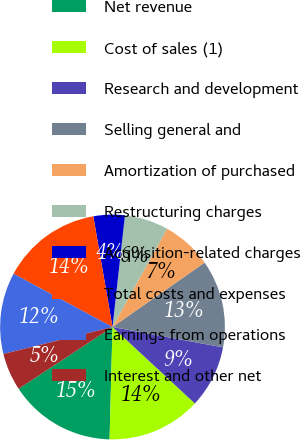<chart> <loc_0><loc_0><loc_500><loc_500><pie_chart><fcel>Net revenue<fcel>Cost of sales (1)<fcel>Research and development<fcel>Selling general and<fcel>Amortization of purchased<fcel>Restructuring charges<fcel>Acquisition-related charges<fcel>Total costs and expenses<fcel>Earnings from operations<fcel>Interest and other net<nl><fcel>15.32%<fcel>13.51%<fcel>9.01%<fcel>12.61%<fcel>7.21%<fcel>6.31%<fcel>4.5%<fcel>14.41%<fcel>11.71%<fcel>5.41%<nl></chart> 